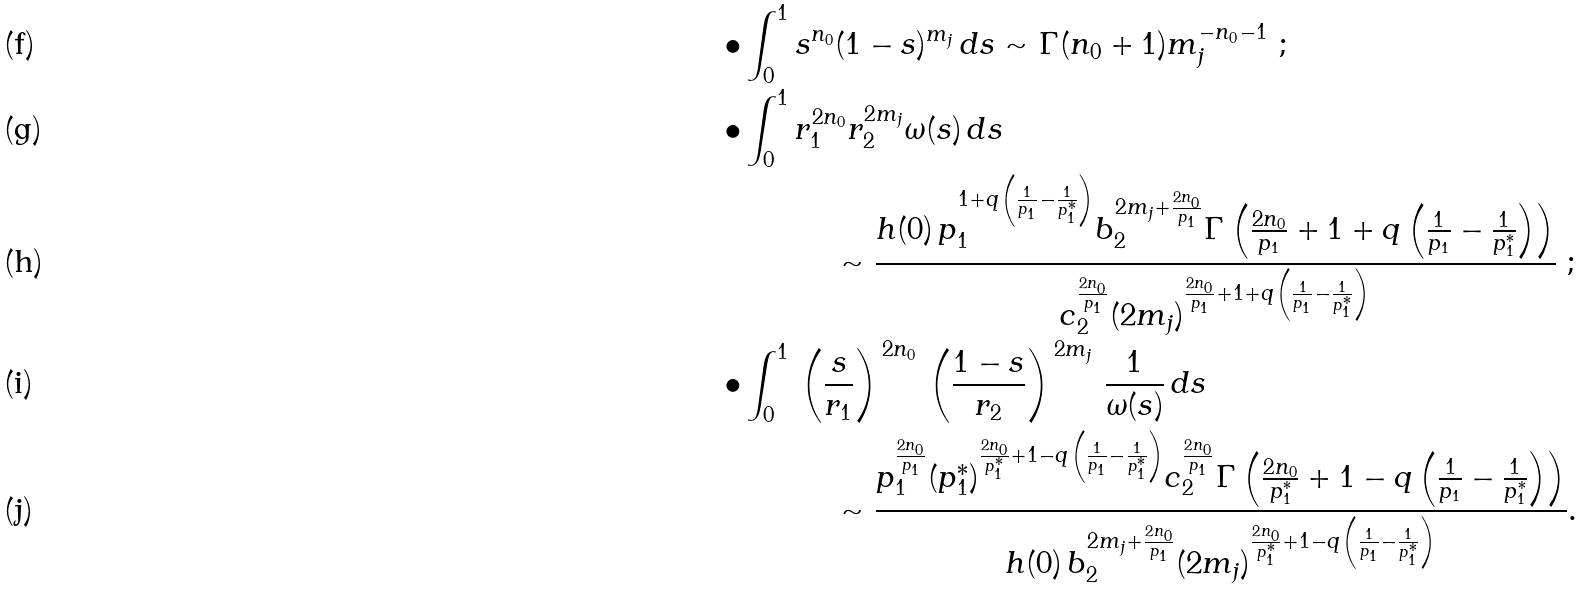<formula> <loc_0><loc_0><loc_500><loc_500>\bullet \int _ { 0 } ^ { 1 } & \, s ^ { n _ { 0 } } ( 1 - s ) ^ { m _ { j } } \, d s \sim \Gamma ( n _ { 0 } + 1 ) m _ { j } ^ { - n _ { 0 } - 1 } \ ; \\ \bullet \int _ { 0 } ^ { 1 } & \, r _ { 1 } ^ { 2 n _ { 0 } } r _ { 2 } ^ { 2 m _ { j } } \omega ( s ) \, d s \ \\ & \quad \ \sim \frac { h ( 0 ) \, p _ { 1 } ^ { 1 + q \left ( \frac { 1 } { p _ { 1 } } - \frac { 1 } { p _ { 1 } ^ { * } } \right ) } b _ { 2 } ^ { 2 m _ { j } + \frac { 2 n _ { 0 } } { p _ { 1 } } } \Gamma \left ( \frac { 2 n _ { 0 } } { p _ { 1 } } + 1 + q \left ( \frac { 1 } { p _ { 1 } } - \frac { 1 } { p _ { 1 } ^ { * } } \right ) \right ) } { c _ { 2 } ^ { \frac { 2 n _ { 0 } } { p _ { 1 } } } ( 2 m _ { j } ) ^ { \frac { 2 n _ { 0 } } { p _ { 1 } } + 1 + q \left ( \frac { 1 } { p _ { 1 } } - \frac { 1 } { p _ { 1 } ^ { * } } \right ) } } \ ; \\ \bullet \int _ { 0 } ^ { 1 } & \, \left ( \frac { s } { r _ { 1 } } \right ) ^ { \, 2 n _ { 0 } } \, \left ( \frac { 1 - s } { r _ { 2 } } \right ) ^ { \, 2 m _ { j } } \, \frac { 1 } { \omega ( s ) } \, d s \\ & \quad \ \sim \frac { p _ { 1 } ^ { \frac { 2 n _ { 0 } } { p _ { 1 } } } ( p ^ { * } _ { 1 } ) ^ { \frac { 2 n _ { 0 } } { p _ { 1 } ^ { * } } + 1 - q \left ( \frac { 1 } { p _ { 1 } } - \frac { 1 } { p _ { 1 } ^ { * } } \right ) } c _ { 2 } ^ { \frac { 2 n _ { 0 } } { p _ { 1 } } } \Gamma \left ( \frac { 2 n _ { 0 } } { p ^ { * } _ { 1 } } + 1 - q \left ( \frac { 1 } { p _ { 1 } } - \frac { 1 } { p _ { 1 } ^ { * } } \right ) \right ) } { h ( 0 ) \, b _ { 2 } ^ { 2 m _ { j } + \frac { 2 n _ { 0 } } { p _ { 1 } } } ( 2 m _ { j } ) ^ { \frac { 2 n _ { 0 } } { p ^ { * } _ { 1 } } + 1 - q \left ( \frac { 1 } { p _ { 1 } } - \frac { 1 } { p _ { 1 } ^ { * } } \right ) } } .</formula> 